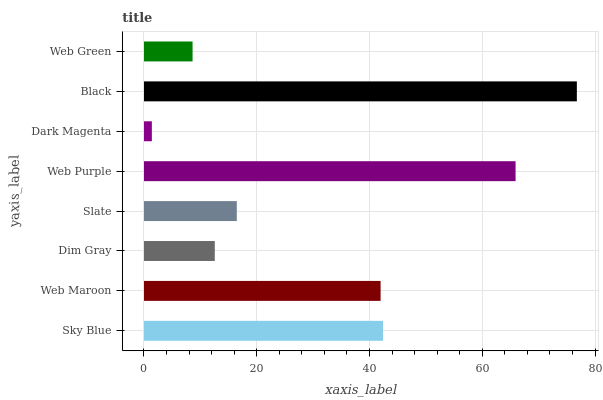Is Dark Magenta the minimum?
Answer yes or no. Yes. Is Black the maximum?
Answer yes or no. Yes. Is Web Maroon the minimum?
Answer yes or no. No. Is Web Maroon the maximum?
Answer yes or no. No. Is Sky Blue greater than Web Maroon?
Answer yes or no. Yes. Is Web Maroon less than Sky Blue?
Answer yes or no. Yes. Is Web Maroon greater than Sky Blue?
Answer yes or no. No. Is Sky Blue less than Web Maroon?
Answer yes or no. No. Is Web Maroon the high median?
Answer yes or no. Yes. Is Slate the low median?
Answer yes or no. Yes. Is Web Green the high median?
Answer yes or no. No. Is Black the low median?
Answer yes or no. No. 